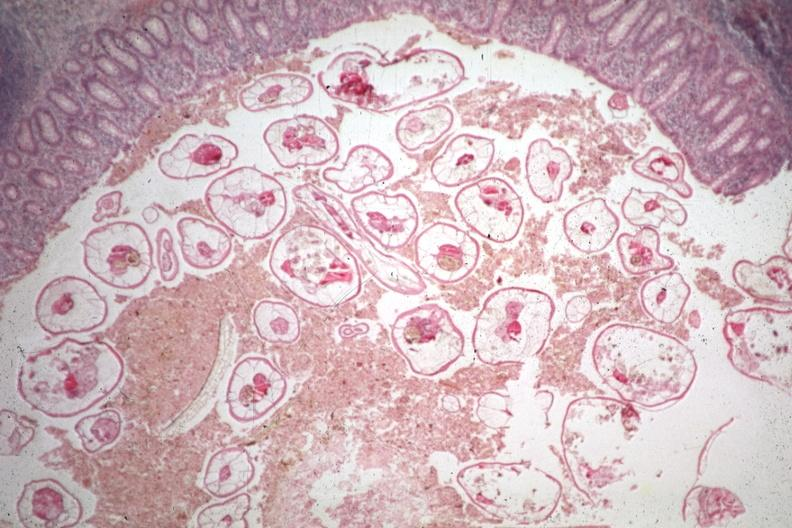what is present?
Answer the question using a single word or phrase. Pinworm 